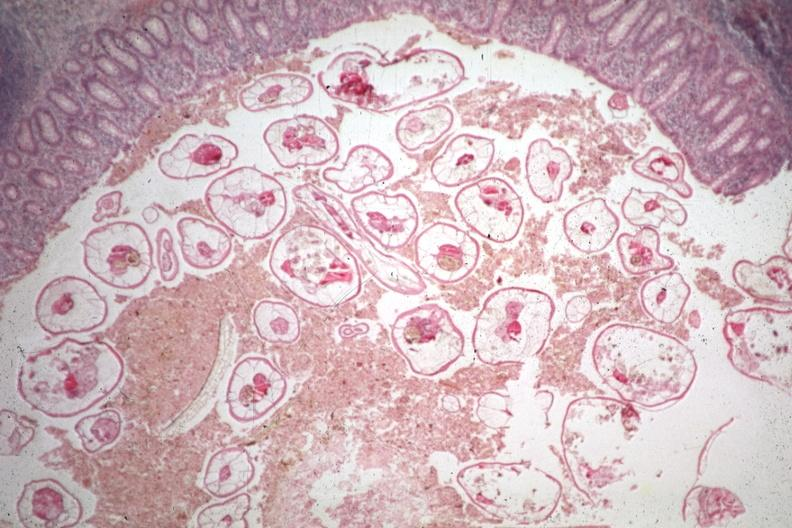what is present?
Answer the question using a single word or phrase. Pinworm 